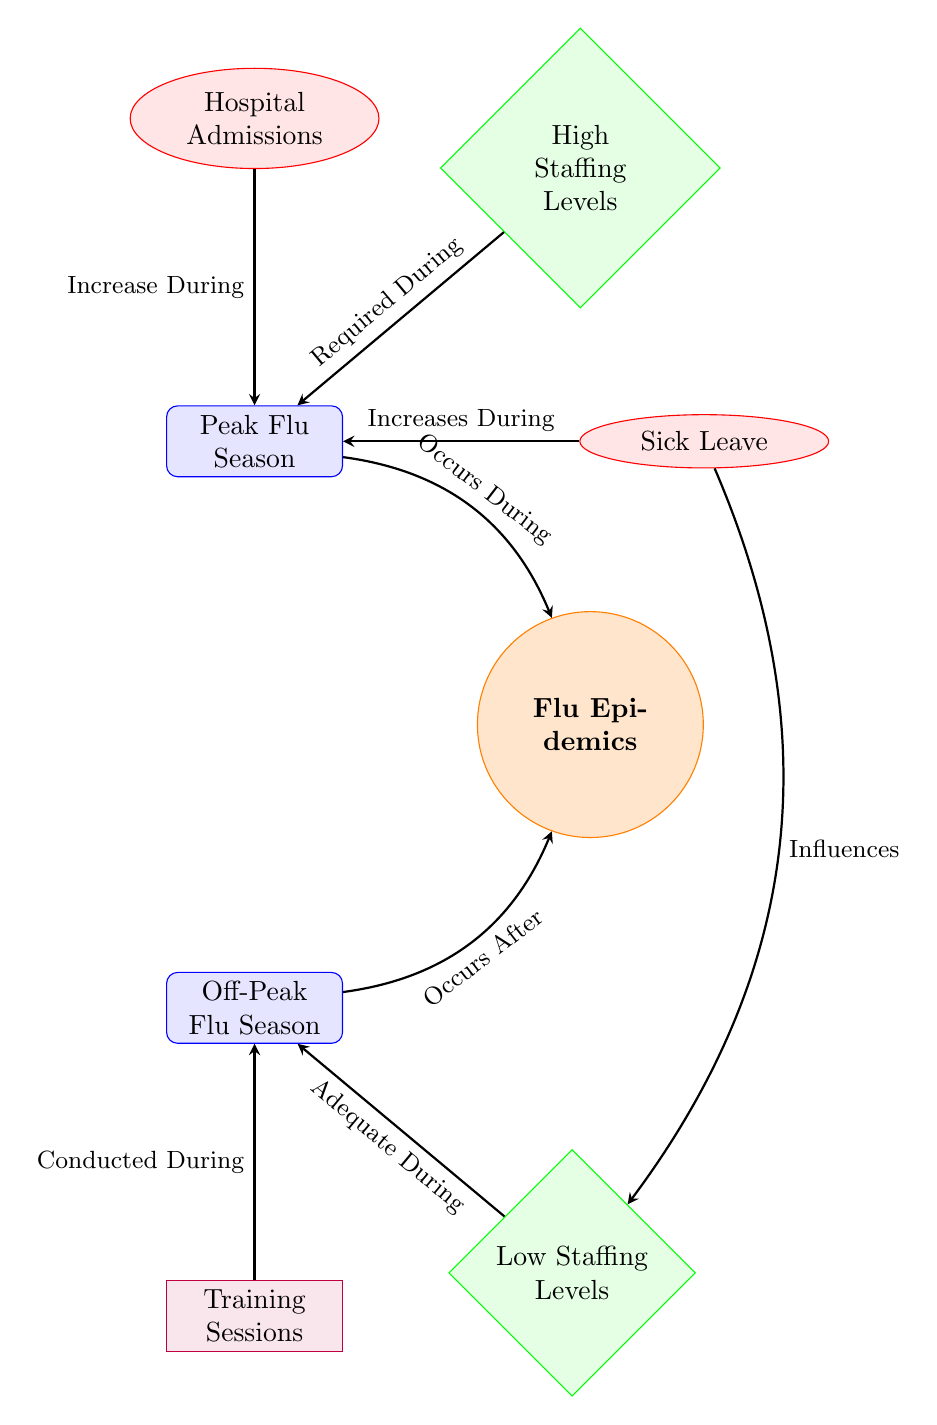What is the central node of the diagram? The central node in the diagram is labeled "Flu Epidemics," which serves as the main focus around which other nodes are organized.
Answer: Flu Epidemics How many event nodes are present in the diagram? The diagram contains two event nodes: "Peak Flu Season" and "Off-Peak Flu Season." This is counted by visually inspecting the nodes categorized as events.
Answer: 2 What is required during the peak flu season? The diagram indicates that "High Staffing Levels" are required during the "Peak Flu Season" as shown by the arrow pointing from the high staffing level node to the peak node.
Answer: High Staffing Levels What happens to hospital admissions during the peak flu season? The flow of the diagram shows that "Hospital Admissions" increase during the "Peak Flu Season," as indicated by the arrow connecting the admissions metric node to the peak event node.
Answer: Increase What is the relationship between sick leave and low staffing levels? The diagram illustrates that "Sick Leave" influences "Low Staffing Levels," shown by an arrow from the sick leave node bending left towards the low staffing level node.
Answer: Influences During which season are training sessions conducted? The diagram clearly shows that "Training Sessions" are conducted during the "Off-Peak Flu Season," represented by the arrow that connects the training initiative node to the off-peak event node.
Answer: Off-Peak Flu Season What influences occur during the peak flu season? The diagram highlights that both "Hospital Admissions" and "Sick Leave" increase during the "Peak Flu Season," as evidenced by the arrows directing towards the peak event.
Answer: Increase What is adequate during the off-peak flu season? The node labeled "Low Staffing Levels" is declared adequate during the "Off-Peak Flu Season," as indicated by the arrow leading from the low staffing level node to the off-peak event node.
Answer: Adequate During 